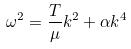Convert formula to latex. <formula><loc_0><loc_0><loc_500><loc_500>\omega ^ { 2 } = \frac { T } { \mu } k ^ { 2 } + \alpha k ^ { 4 }</formula> 